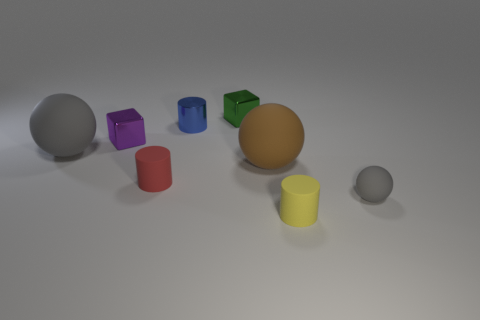Add 2 small green things. How many objects exist? 10 Subtract all cubes. How many objects are left? 6 Subtract 0 purple spheres. How many objects are left? 8 Subtract all metallic cylinders. Subtract all small metallic cylinders. How many objects are left? 6 Add 7 red rubber cylinders. How many red rubber cylinders are left? 8 Add 3 small shiny blocks. How many small shiny blocks exist? 5 